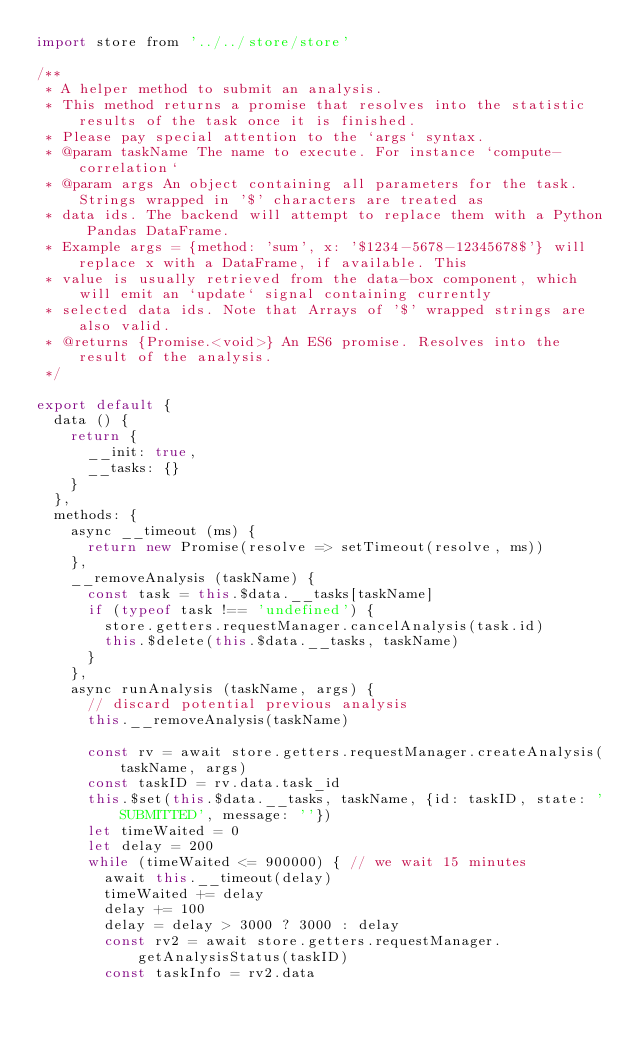Convert code to text. <code><loc_0><loc_0><loc_500><loc_500><_JavaScript_>import store from '../../store/store'

/**
 * A helper method to submit an analysis.
 * This method returns a promise that resolves into the statistic results of the task once it is finished.
 * Please pay special attention to the `args` syntax.
 * @param taskName The name to execute. For instance `compute-correlation`
 * @param args An object containing all parameters for the task. Strings wrapped in '$' characters are treated as
 * data ids. The backend will attempt to replace them with a Python Pandas DataFrame.
 * Example args = {method: 'sum', x: '$1234-5678-12345678$'} will replace x with a DataFrame, if available. This
 * value is usually retrieved from the data-box component, which will emit an `update` signal containing currently
 * selected data ids. Note that Arrays of '$' wrapped strings are also valid.
 * @returns {Promise.<void>} An ES6 promise. Resolves into the result of the analysis.
 */

export default {
  data () {
    return {
      __init: true,
      __tasks: {}
    }
  },
  methods: {
    async __timeout (ms) {
      return new Promise(resolve => setTimeout(resolve, ms))
    },
    __removeAnalysis (taskName) {
      const task = this.$data.__tasks[taskName]
      if (typeof task !== 'undefined') {
        store.getters.requestManager.cancelAnalysis(task.id)
        this.$delete(this.$data.__tasks, taskName)
      }
    },
    async runAnalysis (taskName, args) {
      // discard potential previous analysis
      this.__removeAnalysis(taskName)

      const rv = await store.getters.requestManager.createAnalysis(taskName, args)
      const taskID = rv.data.task_id
      this.$set(this.$data.__tasks, taskName, {id: taskID, state: 'SUBMITTED', message: ''})
      let timeWaited = 0
      let delay = 200
      while (timeWaited <= 900000) { // we wait 15 minutes
        await this.__timeout(delay)
        timeWaited += delay
        delay += 100
        delay = delay > 3000 ? 3000 : delay
        const rv2 = await store.getters.requestManager.getAnalysisStatus(taskID)
        const taskInfo = rv2.data</code> 